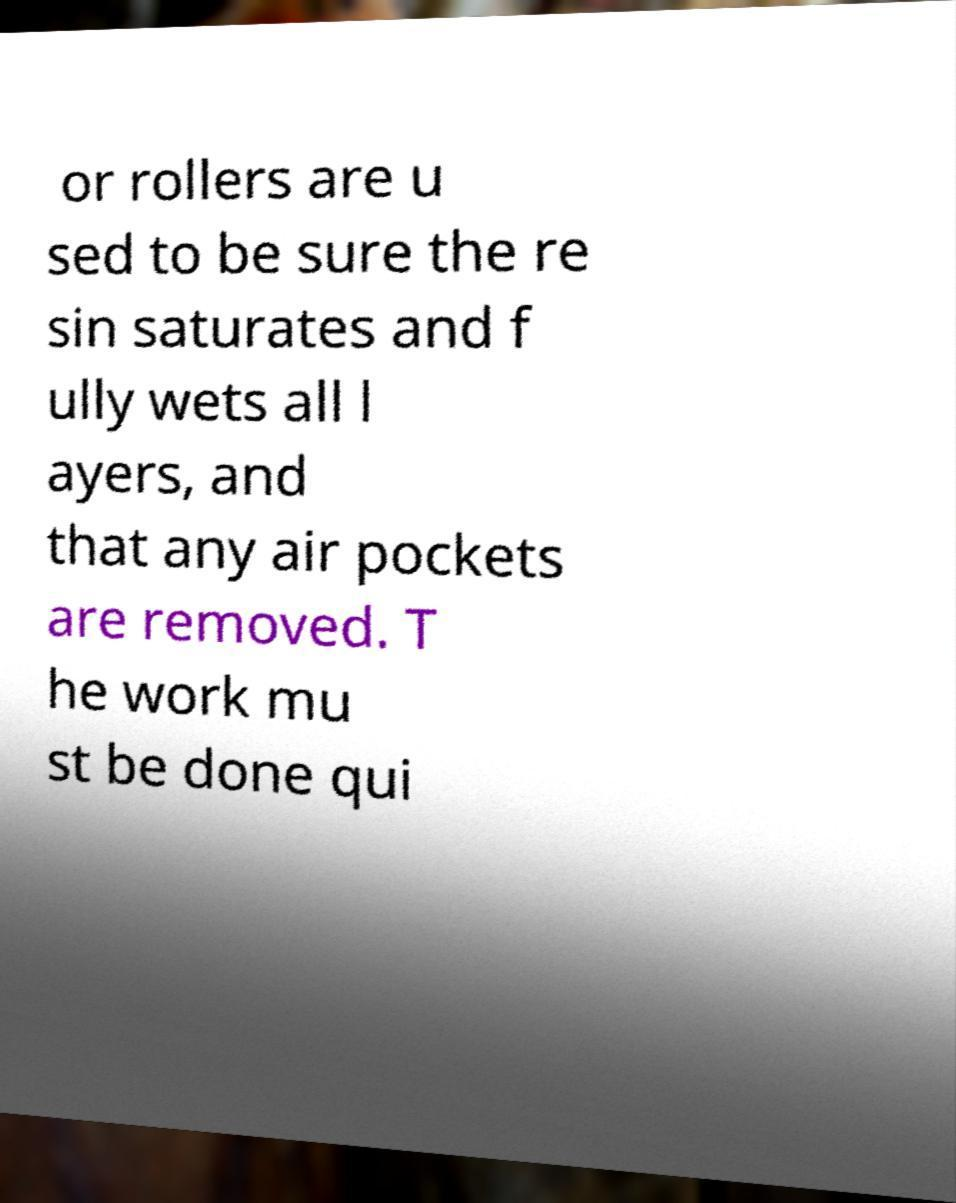Could you assist in decoding the text presented in this image and type it out clearly? or rollers are u sed to be sure the re sin saturates and f ully wets all l ayers, and that any air pockets are removed. T he work mu st be done qui 